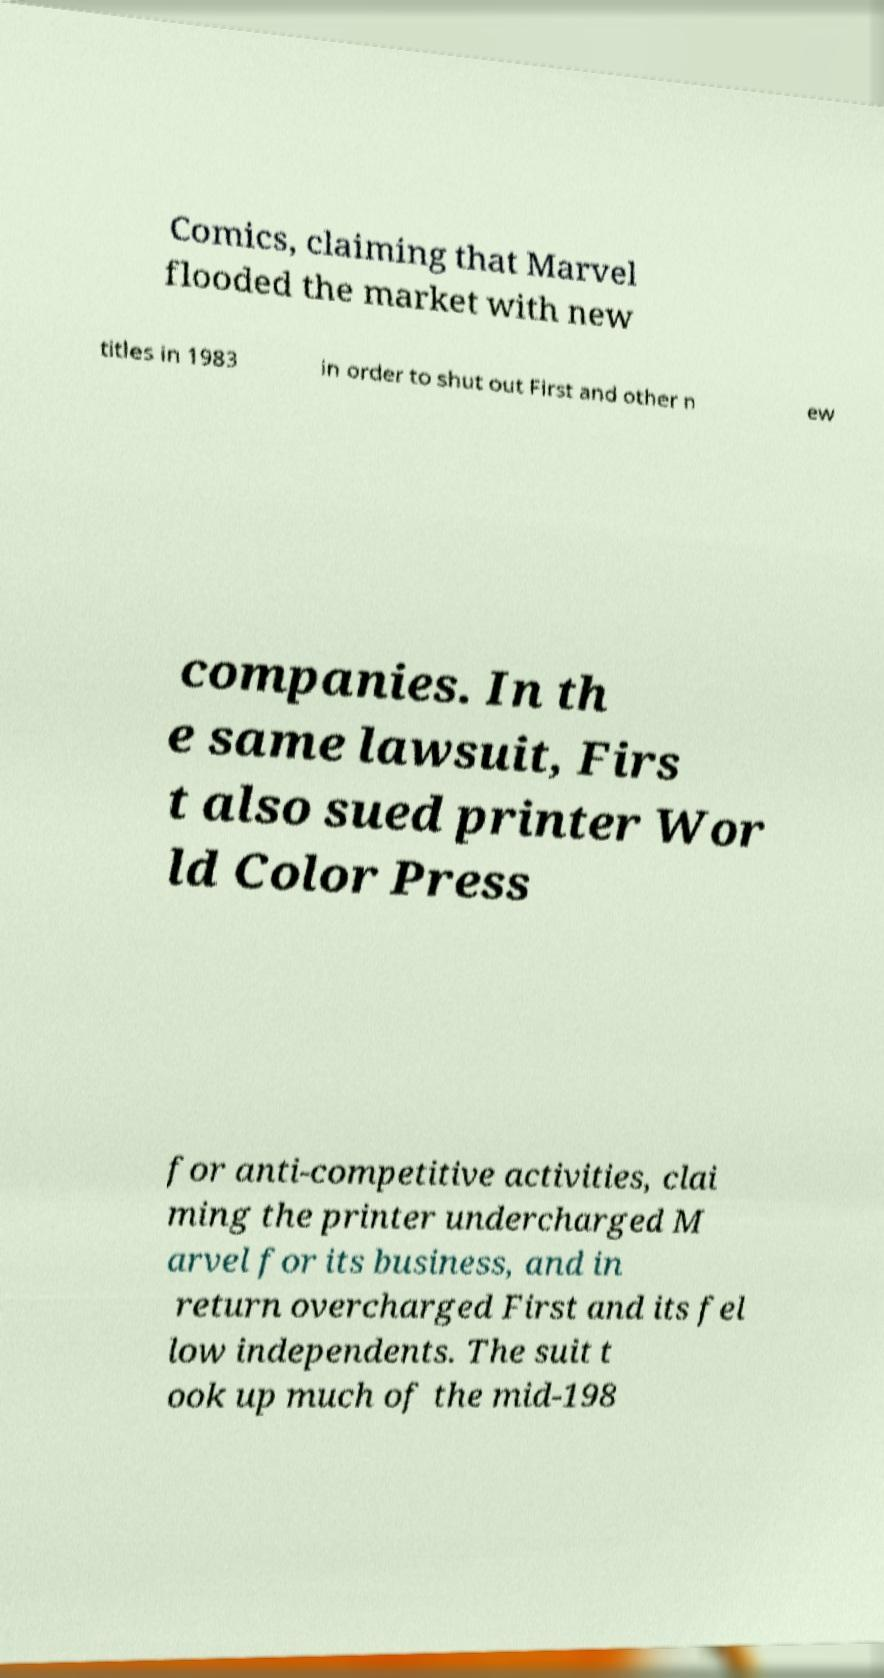Please identify and transcribe the text found in this image. Comics, claiming that Marvel flooded the market with new titles in 1983 in order to shut out First and other n ew companies. In th e same lawsuit, Firs t also sued printer Wor ld Color Press for anti-competitive activities, clai ming the printer undercharged M arvel for its business, and in return overcharged First and its fel low independents. The suit t ook up much of the mid-198 